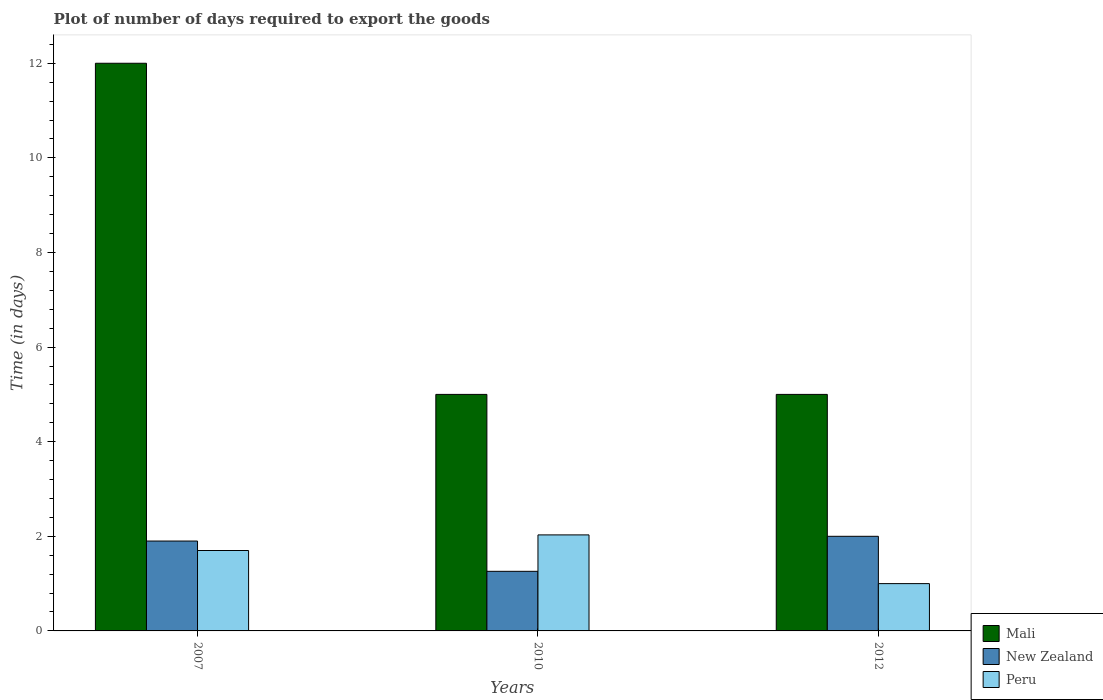Are the number of bars per tick equal to the number of legend labels?
Keep it short and to the point. Yes. Across all years, what is the minimum time required to export goods in Mali?
Offer a very short reply. 5. In which year was the time required to export goods in Mali maximum?
Provide a short and direct response. 2007. In which year was the time required to export goods in New Zealand minimum?
Offer a terse response. 2010. What is the total time required to export goods in Peru in the graph?
Give a very brief answer. 4.73. What is the difference between the time required to export goods in Mali in 2007 and that in 2012?
Ensure brevity in your answer.  7. What is the difference between the time required to export goods in Mali in 2007 and the time required to export goods in Peru in 2012?
Offer a terse response. 11. What is the average time required to export goods in Mali per year?
Offer a very short reply. 7.33. In how many years, is the time required to export goods in Peru greater than 5.2 days?
Your response must be concise. 0. What is the ratio of the time required to export goods in Mali in 2010 to that in 2012?
Provide a short and direct response. 1. Is the time required to export goods in Peru in 2010 less than that in 2012?
Keep it short and to the point. No. What is the difference between the highest and the second highest time required to export goods in Mali?
Your answer should be compact. 7. What is the difference between the highest and the lowest time required to export goods in Peru?
Keep it short and to the point. 1.03. In how many years, is the time required to export goods in Peru greater than the average time required to export goods in Peru taken over all years?
Your answer should be very brief. 2. Is the sum of the time required to export goods in Mali in 2007 and 2012 greater than the maximum time required to export goods in Peru across all years?
Ensure brevity in your answer.  Yes. What does the 1st bar from the left in 2010 represents?
Keep it short and to the point. Mali. What does the 2nd bar from the right in 2010 represents?
Provide a succinct answer. New Zealand. Are all the bars in the graph horizontal?
Provide a succinct answer. No. What is the difference between two consecutive major ticks on the Y-axis?
Your answer should be very brief. 2. Does the graph contain any zero values?
Offer a terse response. No. How are the legend labels stacked?
Your answer should be very brief. Vertical. What is the title of the graph?
Ensure brevity in your answer.  Plot of number of days required to export the goods. Does "Japan" appear as one of the legend labels in the graph?
Give a very brief answer. No. What is the label or title of the X-axis?
Provide a succinct answer. Years. What is the label or title of the Y-axis?
Give a very brief answer. Time (in days). What is the Time (in days) of New Zealand in 2007?
Make the answer very short. 1.9. What is the Time (in days) of Mali in 2010?
Make the answer very short. 5. What is the Time (in days) in New Zealand in 2010?
Your response must be concise. 1.26. What is the Time (in days) of Peru in 2010?
Your answer should be compact. 2.03. What is the Time (in days) of Peru in 2012?
Offer a very short reply. 1. Across all years, what is the maximum Time (in days) in Peru?
Your answer should be compact. 2.03. Across all years, what is the minimum Time (in days) in New Zealand?
Keep it short and to the point. 1.26. Across all years, what is the minimum Time (in days) in Peru?
Ensure brevity in your answer.  1. What is the total Time (in days) of Mali in the graph?
Ensure brevity in your answer.  22. What is the total Time (in days) in New Zealand in the graph?
Make the answer very short. 5.16. What is the total Time (in days) in Peru in the graph?
Offer a terse response. 4.73. What is the difference between the Time (in days) of New Zealand in 2007 and that in 2010?
Offer a very short reply. 0.64. What is the difference between the Time (in days) in Peru in 2007 and that in 2010?
Give a very brief answer. -0.33. What is the difference between the Time (in days) in New Zealand in 2007 and that in 2012?
Offer a very short reply. -0.1. What is the difference between the Time (in days) in Peru in 2007 and that in 2012?
Give a very brief answer. 0.7. What is the difference between the Time (in days) in New Zealand in 2010 and that in 2012?
Your answer should be very brief. -0.74. What is the difference between the Time (in days) of Mali in 2007 and the Time (in days) of New Zealand in 2010?
Keep it short and to the point. 10.74. What is the difference between the Time (in days) in Mali in 2007 and the Time (in days) in Peru in 2010?
Ensure brevity in your answer.  9.97. What is the difference between the Time (in days) in New Zealand in 2007 and the Time (in days) in Peru in 2010?
Provide a short and direct response. -0.13. What is the difference between the Time (in days) of Mali in 2010 and the Time (in days) of Peru in 2012?
Make the answer very short. 4. What is the difference between the Time (in days) of New Zealand in 2010 and the Time (in days) of Peru in 2012?
Ensure brevity in your answer.  0.26. What is the average Time (in days) in Mali per year?
Your response must be concise. 7.33. What is the average Time (in days) of New Zealand per year?
Your response must be concise. 1.72. What is the average Time (in days) of Peru per year?
Provide a succinct answer. 1.58. In the year 2007, what is the difference between the Time (in days) of Mali and Time (in days) of Peru?
Keep it short and to the point. 10.3. In the year 2007, what is the difference between the Time (in days) in New Zealand and Time (in days) in Peru?
Provide a succinct answer. 0.2. In the year 2010, what is the difference between the Time (in days) in Mali and Time (in days) in New Zealand?
Ensure brevity in your answer.  3.74. In the year 2010, what is the difference between the Time (in days) in Mali and Time (in days) in Peru?
Offer a very short reply. 2.97. In the year 2010, what is the difference between the Time (in days) in New Zealand and Time (in days) in Peru?
Your response must be concise. -0.77. In the year 2012, what is the difference between the Time (in days) of Mali and Time (in days) of Peru?
Give a very brief answer. 4. In the year 2012, what is the difference between the Time (in days) in New Zealand and Time (in days) in Peru?
Ensure brevity in your answer.  1. What is the ratio of the Time (in days) in New Zealand in 2007 to that in 2010?
Give a very brief answer. 1.51. What is the ratio of the Time (in days) of Peru in 2007 to that in 2010?
Your answer should be compact. 0.84. What is the ratio of the Time (in days) in Mali in 2007 to that in 2012?
Your answer should be compact. 2.4. What is the ratio of the Time (in days) of New Zealand in 2007 to that in 2012?
Ensure brevity in your answer.  0.95. What is the ratio of the Time (in days) in Peru in 2007 to that in 2012?
Make the answer very short. 1.7. What is the ratio of the Time (in days) in New Zealand in 2010 to that in 2012?
Offer a very short reply. 0.63. What is the ratio of the Time (in days) of Peru in 2010 to that in 2012?
Give a very brief answer. 2.03. What is the difference between the highest and the second highest Time (in days) of Mali?
Your answer should be compact. 7. What is the difference between the highest and the second highest Time (in days) in New Zealand?
Your answer should be compact. 0.1. What is the difference between the highest and the second highest Time (in days) in Peru?
Your answer should be compact. 0.33. What is the difference between the highest and the lowest Time (in days) of New Zealand?
Your response must be concise. 0.74. 